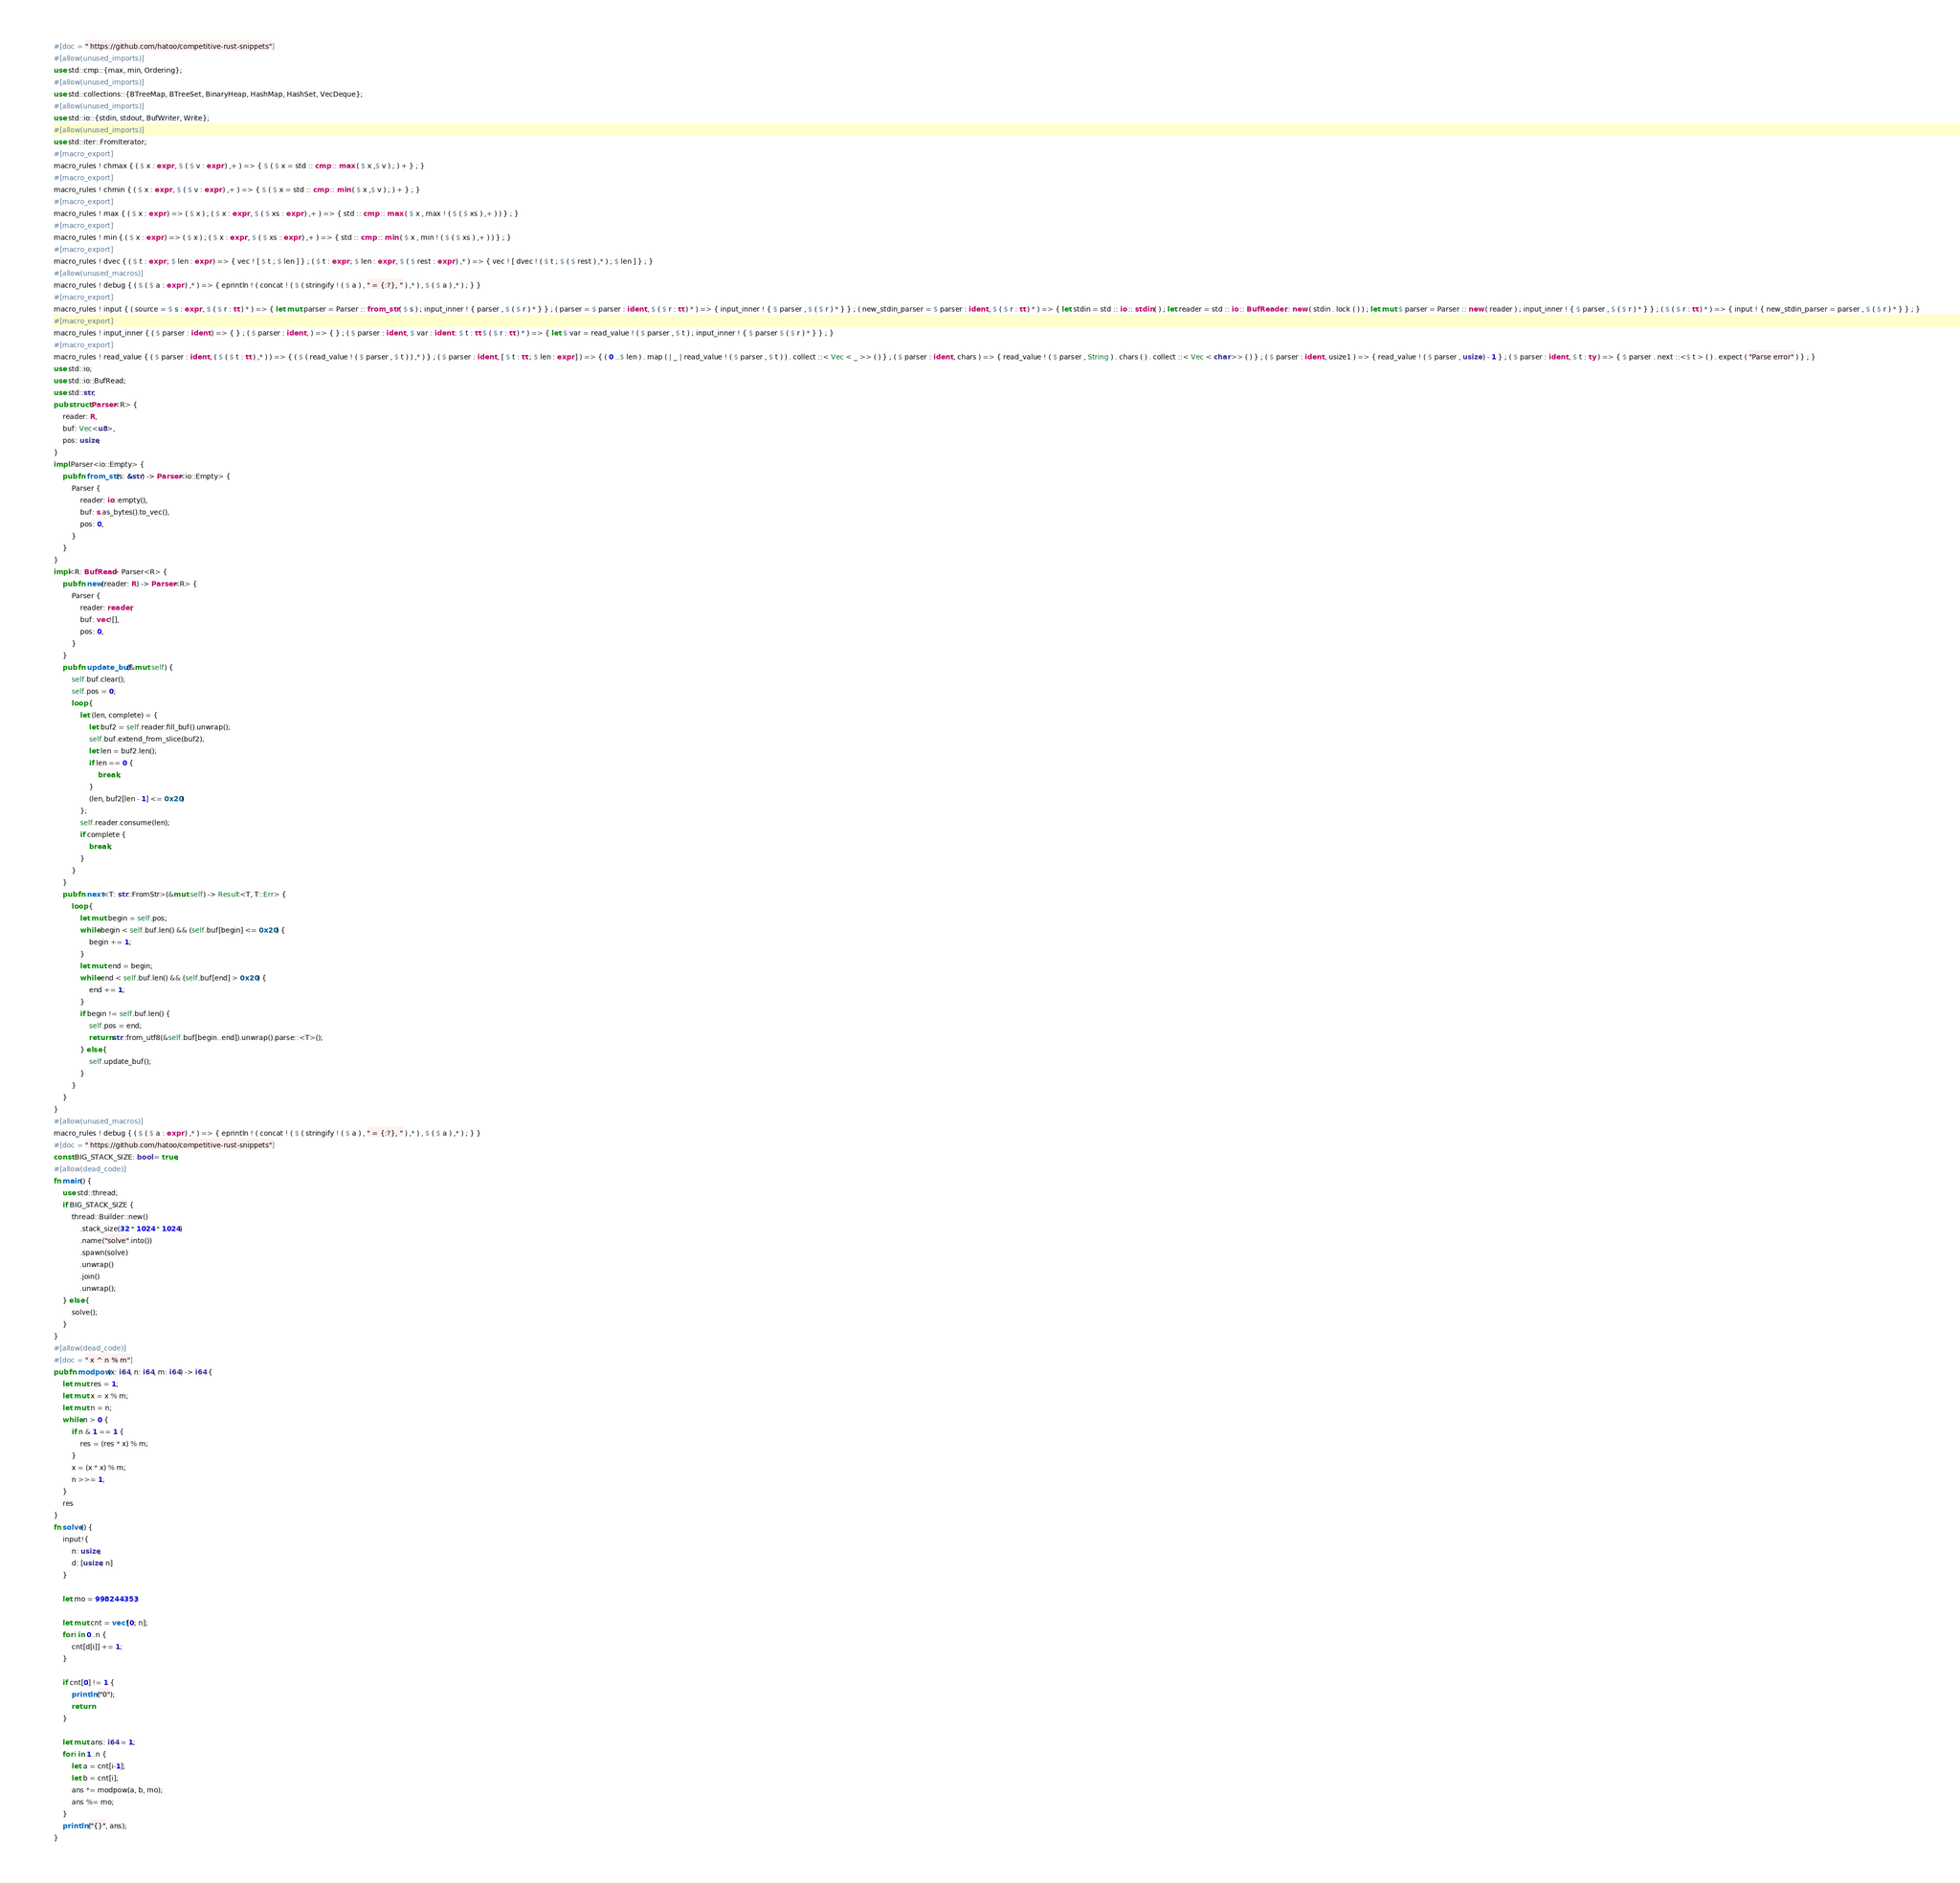<code> <loc_0><loc_0><loc_500><loc_500><_Rust_>#[doc = " https://github.com/hatoo/competitive-rust-snippets"]
#[allow(unused_imports)]
use std::cmp::{max, min, Ordering};
#[allow(unused_imports)]
use std::collections::{BTreeMap, BTreeSet, BinaryHeap, HashMap, HashSet, VecDeque};
#[allow(unused_imports)]
use std::io::{stdin, stdout, BufWriter, Write};
#[allow(unused_imports)]
use std::iter::FromIterator;
#[macro_export]
macro_rules ! chmax { ( $ x : expr , $ ( $ v : expr ) ,+ ) => { $ ( $ x = std :: cmp :: max ( $ x ,$ v ) ; ) + } ; }
#[macro_export]
macro_rules ! chmin { ( $ x : expr , $ ( $ v : expr ) ,+ ) => { $ ( $ x = std :: cmp :: min ( $ x ,$ v ) ; ) + } ; }
#[macro_export]
macro_rules ! max { ( $ x : expr ) => ( $ x ) ; ( $ x : expr , $ ( $ xs : expr ) ,+ ) => { std :: cmp :: max ( $ x , max ! ( $ ( $ xs ) ,+ ) ) } ; }
#[macro_export]
macro_rules ! min { ( $ x : expr ) => ( $ x ) ; ( $ x : expr , $ ( $ xs : expr ) ,+ ) => { std :: cmp :: min ( $ x , min ! ( $ ( $ xs ) ,+ ) ) } ; }
#[macro_export]
macro_rules ! dvec { ( $ t : expr ; $ len : expr ) => { vec ! [ $ t ; $ len ] } ; ( $ t : expr ; $ len : expr , $ ( $ rest : expr ) ,* ) => { vec ! [ dvec ! ( $ t ; $ ( $ rest ) ,* ) ; $ len ] } ; }
#[allow(unused_macros)]
macro_rules ! debug { ( $ ( $ a : expr ) ,* ) => { eprintln ! ( concat ! ( $ ( stringify ! ( $ a ) , " = {:?}, " ) ,* ) , $ ( $ a ) ,* ) ; } }
#[macro_export]
macro_rules ! input { ( source = $ s : expr , $ ( $ r : tt ) * ) => { let mut parser = Parser :: from_str ( $ s ) ; input_inner ! { parser , $ ( $ r ) * } } ; ( parser = $ parser : ident , $ ( $ r : tt ) * ) => { input_inner ! { $ parser , $ ( $ r ) * } } ; ( new_stdin_parser = $ parser : ident , $ ( $ r : tt ) * ) => { let stdin = std :: io :: stdin ( ) ; let reader = std :: io :: BufReader :: new ( stdin . lock ( ) ) ; let mut $ parser = Parser :: new ( reader ) ; input_inner ! { $ parser , $ ( $ r ) * } } ; ( $ ( $ r : tt ) * ) => { input ! { new_stdin_parser = parser , $ ( $ r ) * } } ; }
#[macro_export]
macro_rules ! input_inner { ( $ parser : ident ) => { } ; ( $ parser : ident , ) => { } ; ( $ parser : ident , $ var : ident : $ t : tt $ ( $ r : tt ) * ) => { let $ var = read_value ! ( $ parser , $ t ) ; input_inner ! { $ parser $ ( $ r ) * } } ; }
#[macro_export]
macro_rules ! read_value { ( $ parser : ident , ( $ ( $ t : tt ) ,* ) ) => { ( $ ( read_value ! ( $ parser , $ t ) ) ,* ) } ; ( $ parser : ident , [ $ t : tt ; $ len : expr ] ) => { ( 0 ..$ len ) . map ( | _ | read_value ! ( $ parser , $ t ) ) . collect ::< Vec < _ >> ( ) } ; ( $ parser : ident , chars ) => { read_value ! ( $ parser , String ) . chars ( ) . collect ::< Vec < char >> ( ) } ; ( $ parser : ident , usize1 ) => { read_value ! ( $ parser , usize ) - 1 } ; ( $ parser : ident , $ t : ty ) => { $ parser . next ::<$ t > ( ) . expect ( "Parse error" ) } ; }
use std::io;
use std::io::BufRead;
use std::str;
pub struct Parser<R> {
    reader: R,
    buf: Vec<u8>,
    pos: usize,
}
impl Parser<io::Empty> {
    pub fn from_str(s: &str) -> Parser<io::Empty> {
        Parser {
            reader: io::empty(),
            buf: s.as_bytes().to_vec(),
            pos: 0,
        }
    }
}
impl<R: BufRead> Parser<R> {
    pub fn new(reader: R) -> Parser<R> {
        Parser {
            reader: reader,
            buf: vec![],
            pos: 0,
        }
    }
    pub fn update_buf(&mut self) {
        self.buf.clear();
        self.pos = 0;
        loop {
            let (len, complete) = {
                let buf2 = self.reader.fill_buf().unwrap();
                self.buf.extend_from_slice(buf2);
                let len = buf2.len();
                if len == 0 {
                    break;
                }
                (len, buf2[len - 1] <= 0x20)
            };
            self.reader.consume(len);
            if complete {
                break;
            }
        }
    }
    pub fn next<T: str::FromStr>(&mut self) -> Result<T, T::Err> {
        loop {
            let mut begin = self.pos;
            while begin < self.buf.len() && (self.buf[begin] <= 0x20) {
                begin += 1;
            }
            let mut end = begin;
            while end < self.buf.len() && (self.buf[end] > 0x20) {
                end += 1;
            }
            if begin != self.buf.len() {
                self.pos = end;
                return str::from_utf8(&self.buf[begin..end]).unwrap().parse::<T>();
            } else {
                self.update_buf();
            }
        }
    }
}
#[allow(unused_macros)]
macro_rules ! debug { ( $ ( $ a : expr ) ,* ) => { eprintln ! ( concat ! ( $ ( stringify ! ( $ a ) , " = {:?}, " ) ,* ) , $ ( $ a ) ,* ) ; } }
#[doc = " https://github.com/hatoo/competitive-rust-snippets"]
const BIG_STACK_SIZE: bool = true;
#[allow(dead_code)]
fn main() {
    use std::thread;
    if BIG_STACK_SIZE {
        thread::Builder::new()
            .stack_size(32 * 1024 * 1024)
            .name("solve".into())
            .spawn(solve)
            .unwrap()
            .join()
            .unwrap();
    } else {
        solve();
    }
}
#[allow(dead_code)]
#[doc = " x ^ n % m"]
pub fn modpow(x: i64, n: i64, m: i64) -> i64 {
    let mut res = 1;
    let mut x = x % m;
    let mut n = n;
    while n > 0 {
        if n & 1 == 1 {
            res = (res * x) % m;
        }
        x = (x * x) % m;
        n >>= 1;
    }
    res
}
fn solve() {
    input!{
        n: usize,
        d: [usize; n]
    }

    let mo = 998244353;

    let mut cnt = vec![0; n];
    for i in 0..n {
        cnt[d[i]] += 1;
    }

    if cnt[0] != 1 {
        println!("0");
        return
    }

    let mut ans: i64 = 1;
    for i in 1..n {
        let a = cnt[i-1];
        let b = cnt[i];
        ans *= modpow(a, b, mo);
        ans %= mo;
    }
    println!("{}", ans);
}</code> 